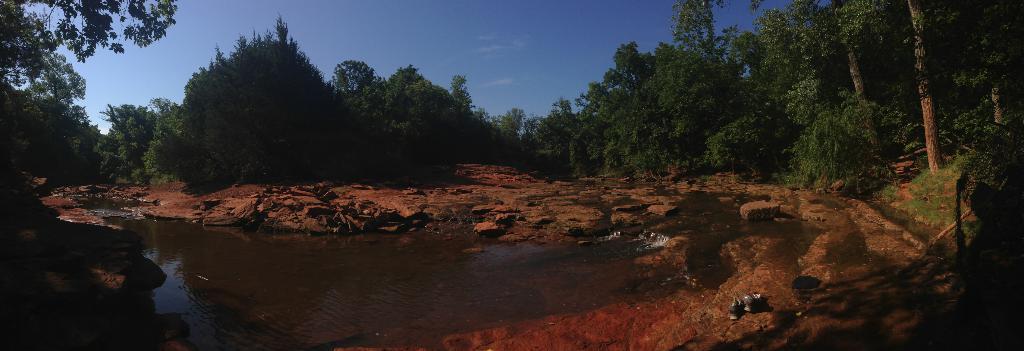Could you give a brief overview of what you see in this image? At the bottom of the picture, we see water and rocks. There are many trees in the background. At the top of the picture, we see the sky. 